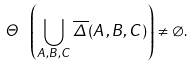<formula> <loc_0><loc_0><loc_500><loc_500>\Theta \ \left ( \bigcup _ { A , B , C } \overline { \Delta } ( A , B , C ) \right ) \neq \varnothing .</formula> 